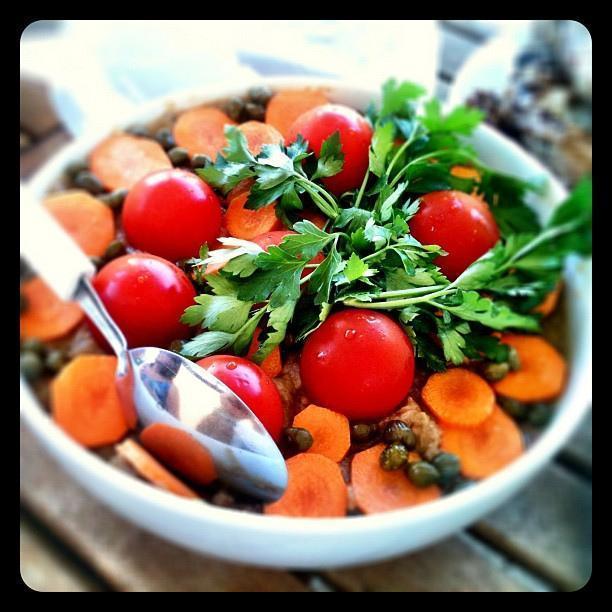How many types of veggies are in the image?
Give a very brief answer. 3. How many carrots are in the picture?
Give a very brief answer. 13. 